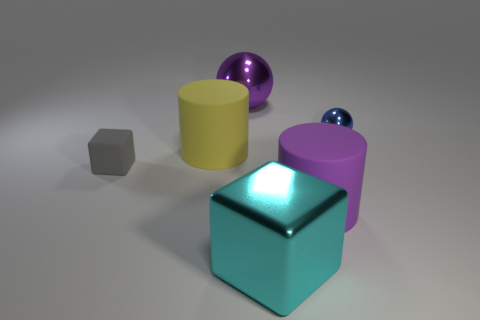Is the number of blue metal objects less than the number of blue cubes?
Provide a short and direct response. No. There is a ball that is on the left side of the tiny blue ball; is it the same color as the small ball?
Make the answer very short. No. How many yellow shiny balls have the same size as the purple sphere?
Your answer should be compact. 0. Is there a large matte cylinder that has the same color as the big shiny ball?
Give a very brief answer. Yes. Are the large purple cylinder and the cyan block made of the same material?
Provide a short and direct response. No. What number of other small matte things are the same shape as the small gray rubber object?
Ensure brevity in your answer.  0. What shape is the large purple object that is made of the same material as the tiny block?
Provide a succinct answer. Cylinder. What is the color of the thing that is on the right side of the big purple object in front of the yellow matte thing?
Offer a very short reply. Blue. Is the metallic block the same color as the big metallic sphere?
Provide a short and direct response. No. There is a large object that is in front of the cylinder that is on the right side of the large purple sphere; what is it made of?
Keep it short and to the point. Metal. 